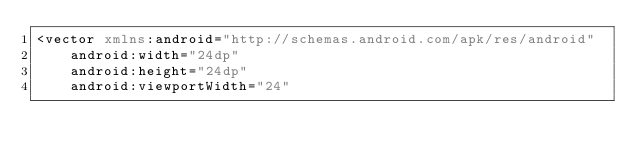Convert code to text. <code><loc_0><loc_0><loc_500><loc_500><_XML_><vector xmlns:android="http://schemas.android.com/apk/res/android"
    android:width="24dp"
    android:height="24dp"
    android:viewportWidth="24"</code> 